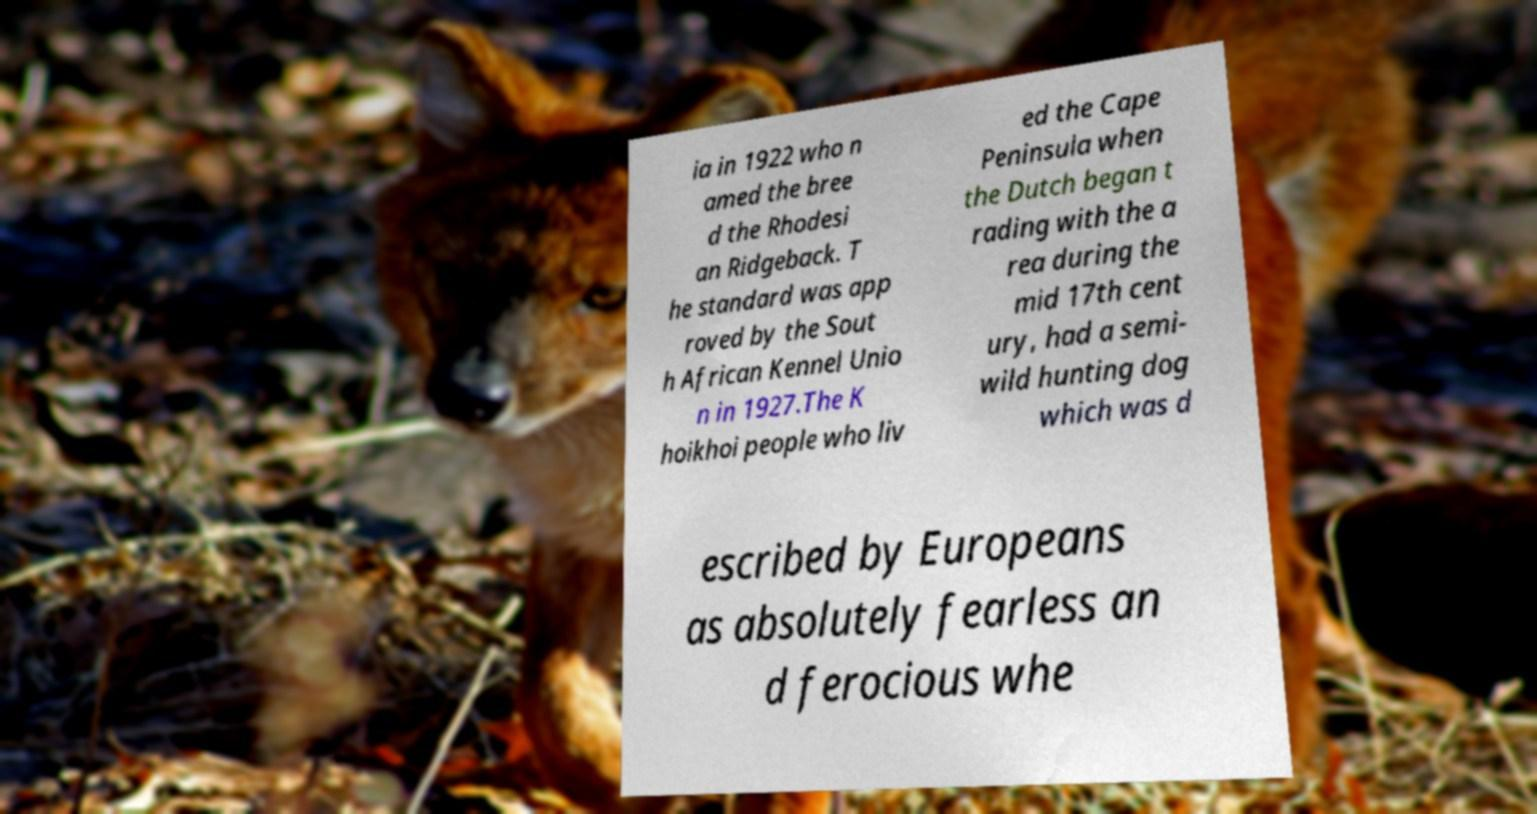What messages or text are displayed in this image? I need them in a readable, typed format. ia in 1922 who n amed the bree d the Rhodesi an Ridgeback. T he standard was app roved by the Sout h African Kennel Unio n in 1927.The K hoikhoi people who liv ed the Cape Peninsula when the Dutch began t rading with the a rea during the mid 17th cent ury, had a semi- wild hunting dog which was d escribed by Europeans as absolutely fearless an d ferocious whe 